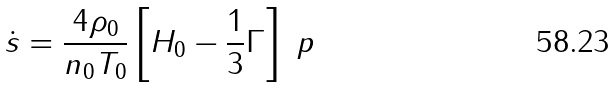<formula> <loc_0><loc_0><loc_500><loc_500>\dot { s } = \frac { 4 \rho _ { 0 } } { n _ { 0 } T _ { 0 } } \left [ H _ { 0 } - \frac { 1 } { 3 } \Gamma \right ] \ p</formula> 